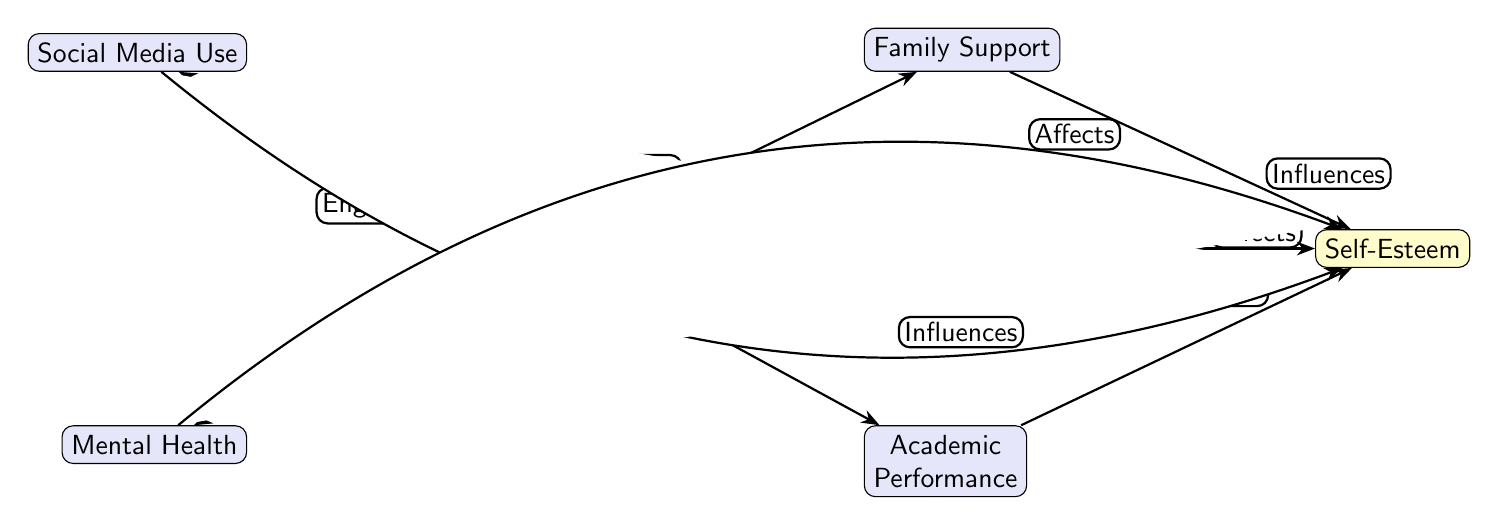What is the central node in the diagram? The central node is "Adolescent", which is the main focus of the diagram and shows the influences and outcomes related to self-esteem development.
Answer: Adolescent How many nodes are present in the diagram? Counting all the nodes: "Adolescent", "Family Support", "Peer Relations", "Academic Performance", "Social Media Use", "Mental Health", and "Self-Esteem" gives a total of 7 nodes.
Answer: 7 What influences self-esteem according to the diagram? The diagram indicates that "Family Support", "Peer Relations", "Academic Performance", "Social Media Use", and "Mental Health" all have arrows pointing towards "Self-Esteem", suggesting these are direct influences on self-esteem.
Answer: Family Support, Peer Relations, Academic Performance, Social Media Use, Mental Health Which factor is linked to self-esteem through mental health? The diagram shows an arrow from "Mental Health" that affects "Self-Esteem", indicating that mental health is a factor impacting self-esteem.
Answer: Mental Health Which influences interact directly with the adolescent? The diagram lists "Family Support", "Peer Relations", "Academic Performance", "Social Media Use", and "Mental Health" as interacting influences with "Adolescent", suggesting all of these influences are relevant in the context of self-esteem.
Answer: Family Support, Peer Relations, Academic Performance, Social Media Use, Mental Health What is the purpose of the arrow labeled "Affects" connecting Mental Health to Self-Esteem? The arrow labeled "Affects" indicates that Mental Health has a direct impact on Self-Esteem, suggesting that a person's mental health can influence their self-esteem levels in a significant way.
Answer: Affects Which factor has a bidirectional relationship with self-esteem? The relationships in the diagram show that both "Peer Relations" and "Self-Esteem" interact, meaning that social interactions among peers and how an adolescent feels about themselves may influence each other.
Answer: Peer Relations What type of relationship is suggested between Family Support and Self-Esteem? The arrow from "Family Support" to "Self-Esteem" is labeled "Influences", suggesting that the support one receives from family can have a positive influence on their self-esteem.
Answer: Influences 